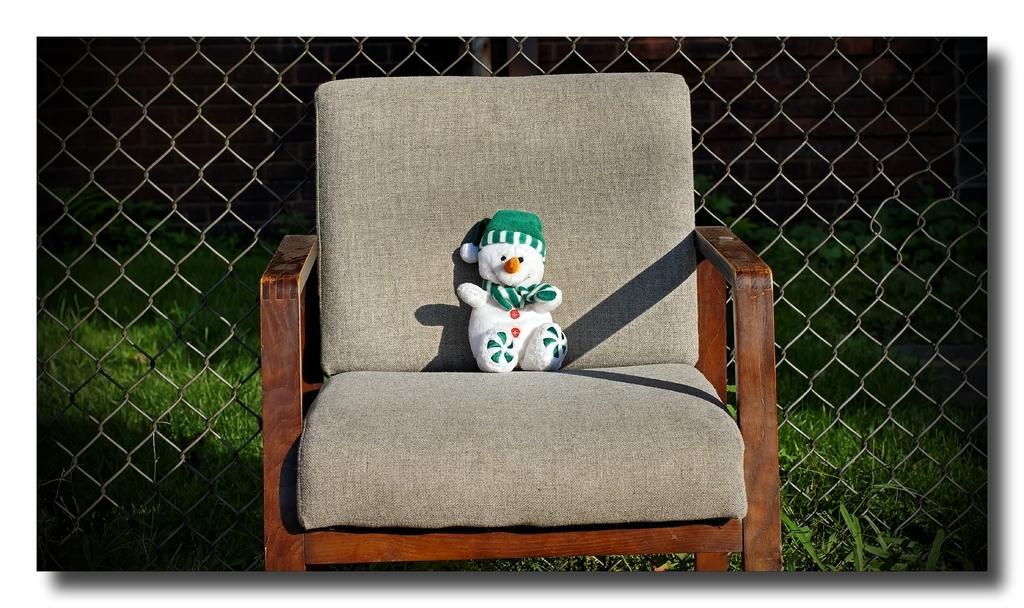In one or two sentences, can you explain what this image depicts? There is a chair. On the chair there is a white, green and orange doll. In the background there is a metal mesh and grasses are over there. 